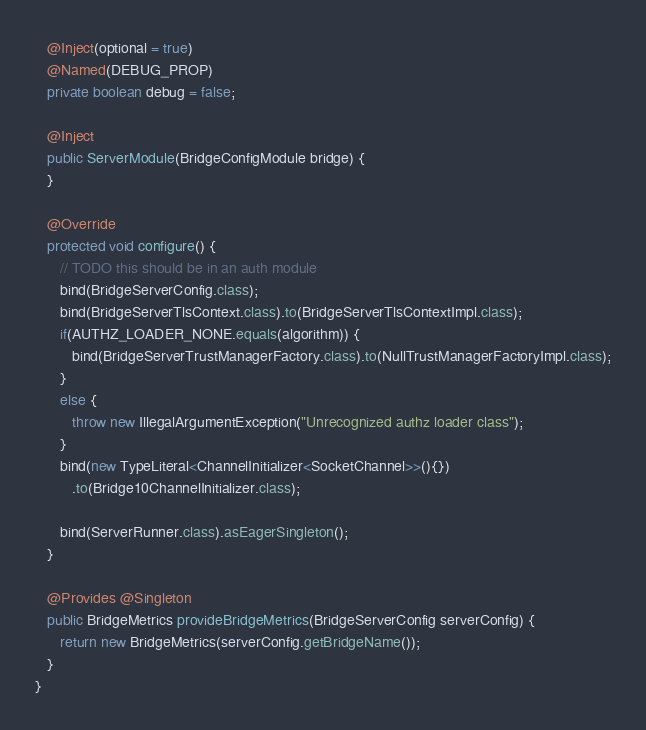Convert code to text. <code><loc_0><loc_0><loc_500><loc_500><_Java_>   @Inject(optional = true)
   @Named(DEBUG_PROP)
   private boolean debug = false;

   @Inject
   public ServerModule(BridgeConfigModule bridge) {
   }

   @Override
   protected void configure() {
      // TODO this should be in an auth module
      bind(BridgeServerConfig.class);
      bind(BridgeServerTlsContext.class).to(BridgeServerTlsContextImpl.class);
      if(AUTHZ_LOADER_NONE.equals(algorithm)) {
         bind(BridgeServerTrustManagerFactory.class).to(NullTrustManagerFactoryImpl.class);
      }
      else {
         throw new IllegalArgumentException("Unrecognized authz loader class");
      }
      bind(new TypeLiteral<ChannelInitializer<SocketChannel>>(){})
         .to(Bridge10ChannelInitializer.class);

      bind(ServerRunner.class).asEagerSingleton();
   }

   @Provides @Singleton
   public BridgeMetrics provideBridgeMetrics(BridgeServerConfig serverConfig) {
      return new BridgeMetrics(serverConfig.getBridgeName());
   }
}

</code> 